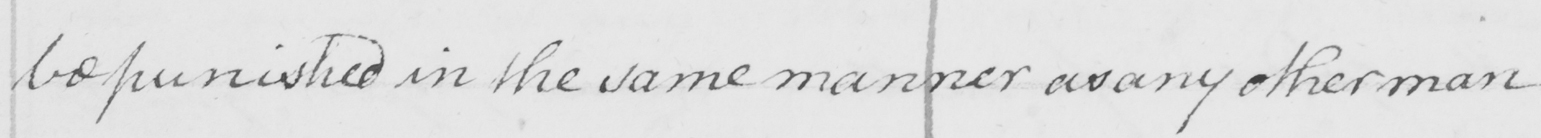Can you read and transcribe this handwriting? be punished in the same manner as any other man 